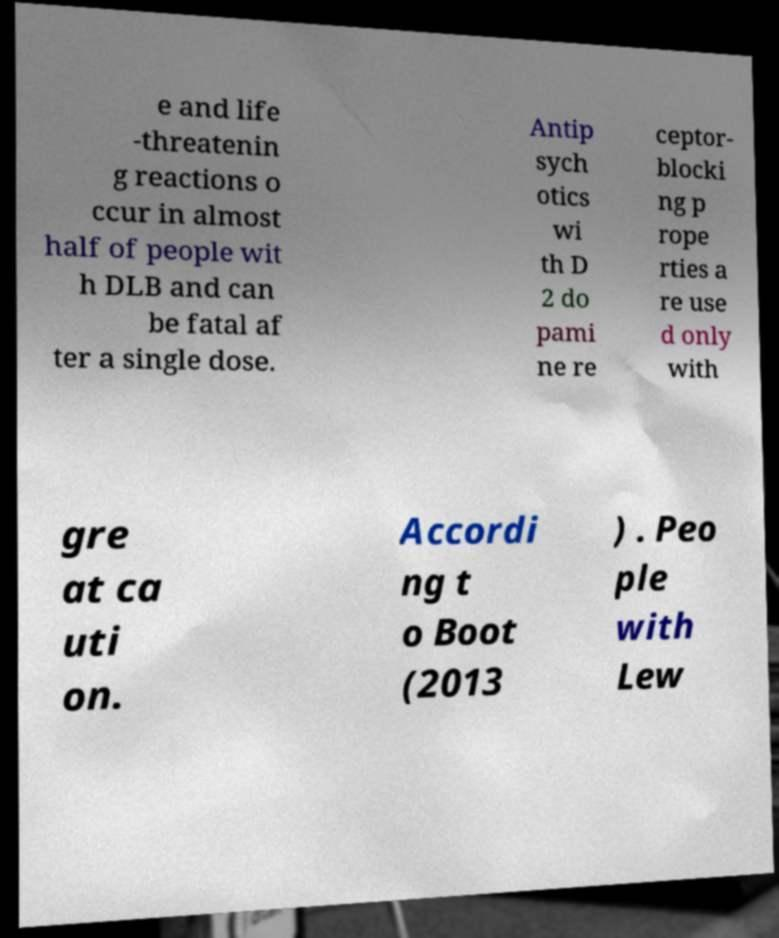Can you accurately transcribe the text from the provided image for me? e and life -threatenin g reactions o ccur in almost half of people wit h DLB and can be fatal af ter a single dose. Antip sych otics wi th D 2 do pami ne re ceptor- blocki ng p rope rties a re use d only with gre at ca uti on. Accordi ng t o Boot (2013 ) . Peo ple with Lew 